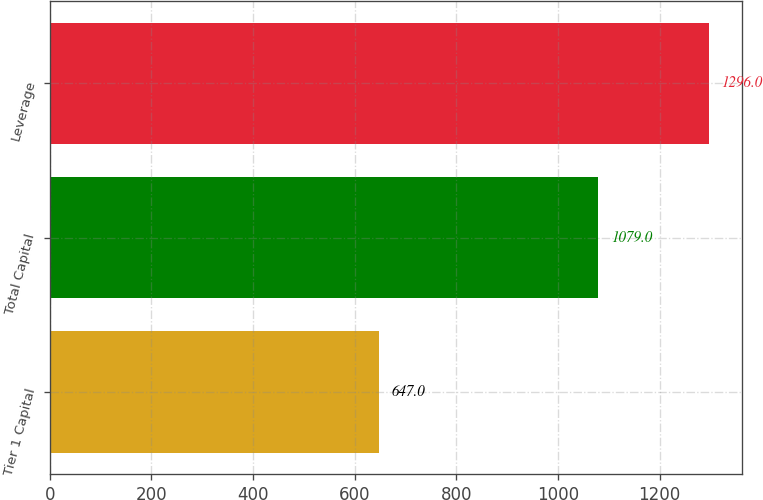Convert chart to OTSL. <chart><loc_0><loc_0><loc_500><loc_500><bar_chart><fcel>Tier 1 Capital<fcel>Total Capital<fcel>Leverage<nl><fcel>647<fcel>1079<fcel>1296<nl></chart> 